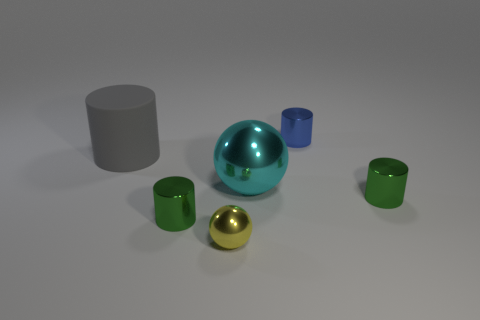What is the color of the rubber cylinder that is the same size as the cyan metal ball?
Provide a short and direct response. Gray. How many objects are spheres that are behind the yellow metal thing or cyan cubes?
Ensure brevity in your answer.  1. How many other objects are the same size as the cyan shiny ball?
Provide a short and direct response. 1. There is a metallic thing right of the tiny blue metallic cylinder; how big is it?
Ensure brevity in your answer.  Small. The yellow thing that is made of the same material as the large sphere is what shape?
Offer a terse response. Sphere. What is the color of the small metal object that is behind the big object in front of the gray matte cylinder?
Provide a succinct answer. Blue. How many large objects are cyan metallic things or yellow things?
Your response must be concise. 1. There is a small blue thing that is the same shape as the gray rubber object; what is it made of?
Keep it short and to the point. Metal. Is there any other thing that has the same material as the large cyan ball?
Keep it short and to the point. Yes. The big ball has what color?
Ensure brevity in your answer.  Cyan. 